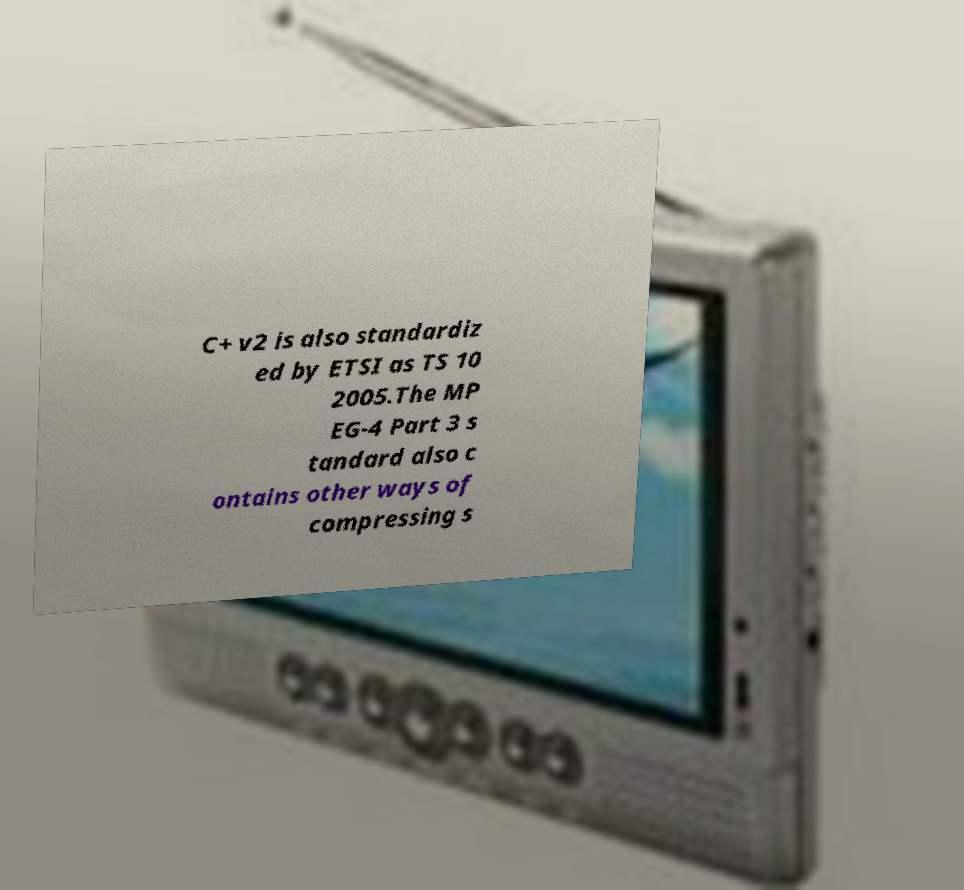For documentation purposes, I need the text within this image transcribed. Could you provide that? C+ v2 is also standardiz ed by ETSI as TS 10 2005.The MP EG-4 Part 3 s tandard also c ontains other ways of compressing s 